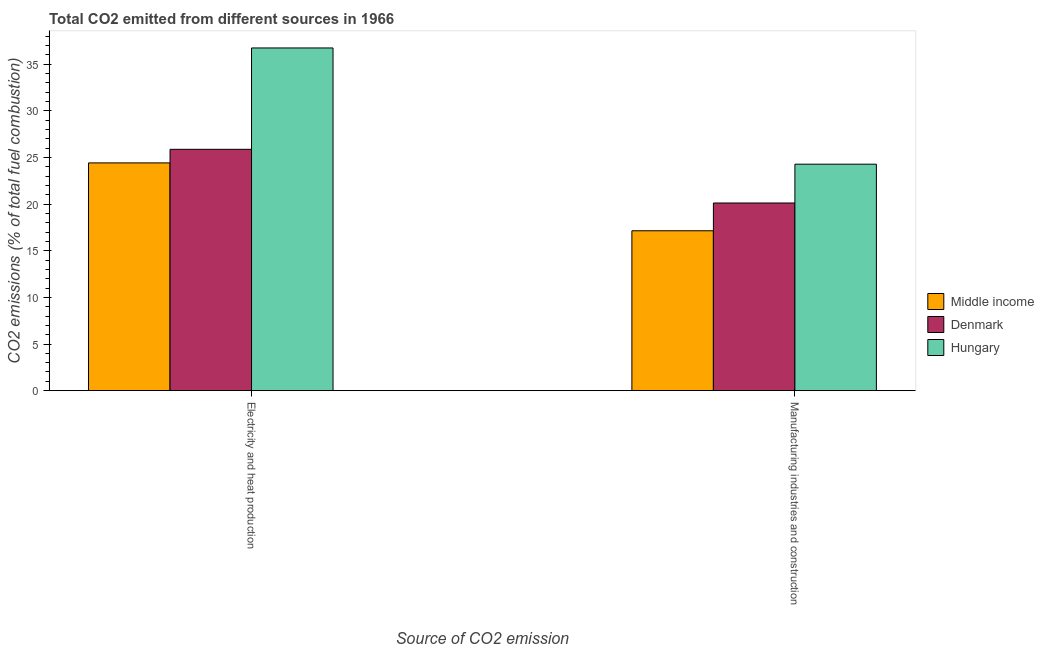How many different coloured bars are there?
Offer a terse response. 3. Are the number of bars per tick equal to the number of legend labels?
Offer a very short reply. Yes. Are the number of bars on each tick of the X-axis equal?
Your answer should be compact. Yes. How many bars are there on the 2nd tick from the left?
Your answer should be compact. 3. How many bars are there on the 2nd tick from the right?
Ensure brevity in your answer.  3. What is the label of the 1st group of bars from the left?
Your answer should be compact. Electricity and heat production. What is the co2 emissions due to electricity and heat production in Middle income?
Give a very brief answer. 24.43. Across all countries, what is the maximum co2 emissions due to electricity and heat production?
Your response must be concise. 36.75. Across all countries, what is the minimum co2 emissions due to manufacturing industries?
Ensure brevity in your answer.  17.15. In which country was the co2 emissions due to manufacturing industries maximum?
Offer a very short reply. Hungary. What is the total co2 emissions due to electricity and heat production in the graph?
Keep it short and to the point. 87.07. What is the difference between the co2 emissions due to manufacturing industries in Middle income and that in Hungary?
Your answer should be compact. -7.14. What is the difference between the co2 emissions due to manufacturing industries in Denmark and the co2 emissions due to electricity and heat production in Middle income?
Keep it short and to the point. -4.3. What is the average co2 emissions due to manufacturing industries per country?
Provide a succinct answer. 20.52. What is the difference between the co2 emissions due to manufacturing industries and co2 emissions due to electricity and heat production in Middle income?
Provide a short and direct response. -7.28. In how many countries, is the co2 emissions due to manufacturing industries greater than 34 %?
Your answer should be very brief. 0. What is the ratio of the co2 emissions due to electricity and heat production in Denmark to that in Middle income?
Make the answer very short. 1.06. Is the co2 emissions due to manufacturing industries in Denmark less than that in Middle income?
Your answer should be very brief. No. What does the 3rd bar from the left in Manufacturing industries and construction represents?
Provide a short and direct response. Hungary. How many bars are there?
Provide a short and direct response. 6. Are all the bars in the graph horizontal?
Provide a succinct answer. No. What is the difference between two consecutive major ticks on the Y-axis?
Offer a terse response. 5. Are the values on the major ticks of Y-axis written in scientific E-notation?
Your answer should be very brief. No. Does the graph contain any zero values?
Your response must be concise. No. Does the graph contain grids?
Ensure brevity in your answer.  No. Where does the legend appear in the graph?
Give a very brief answer. Center right. How many legend labels are there?
Your answer should be very brief. 3. What is the title of the graph?
Your answer should be very brief. Total CO2 emitted from different sources in 1966. Does "Brunei Darussalam" appear as one of the legend labels in the graph?
Provide a short and direct response. No. What is the label or title of the X-axis?
Your answer should be compact. Source of CO2 emission. What is the label or title of the Y-axis?
Make the answer very short. CO2 emissions (% of total fuel combustion). What is the CO2 emissions (% of total fuel combustion) of Middle income in Electricity and heat production?
Ensure brevity in your answer.  24.43. What is the CO2 emissions (% of total fuel combustion) in Denmark in Electricity and heat production?
Keep it short and to the point. 25.88. What is the CO2 emissions (% of total fuel combustion) of Hungary in Electricity and heat production?
Your answer should be very brief. 36.75. What is the CO2 emissions (% of total fuel combustion) of Middle income in Manufacturing industries and construction?
Ensure brevity in your answer.  17.15. What is the CO2 emissions (% of total fuel combustion) in Denmark in Manufacturing industries and construction?
Offer a very short reply. 20.13. What is the CO2 emissions (% of total fuel combustion) of Hungary in Manufacturing industries and construction?
Ensure brevity in your answer.  24.29. Across all Source of CO2 emission, what is the maximum CO2 emissions (% of total fuel combustion) in Middle income?
Provide a short and direct response. 24.43. Across all Source of CO2 emission, what is the maximum CO2 emissions (% of total fuel combustion) in Denmark?
Make the answer very short. 25.88. Across all Source of CO2 emission, what is the maximum CO2 emissions (% of total fuel combustion) in Hungary?
Your response must be concise. 36.75. Across all Source of CO2 emission, what is the minimum CO2 emissions (% of total fuel combustion) in Middle income?
Ensure brevity in your answer.  17.15. Across all Source of CO2 emission, what is the minimum CO2 emissions (% of total fuel combustion) of Denmark?
Give a very brief answer. 20.13. Across all Source of CO2 emission, what is the minimum CO2 emissions (% of total fuel combustion) in Hungary?
Provide a succinct answer. 24.29. What is the total CO2 emissions (% of total fuel combustion) in Middle income in the graph?
Your answer should be compact. 41.57. What is the total CO2 emissions (% of total fuel combustion) of Denmark in the graph?
Your response must be concise. 46.01. What is the total CO2 emissions (% of total fuel combustion) of Hungary in the graph?
Your answer should be compact. 61.04. What is the difference between the CO2 emissions (% of total fuel combustion) of Middle income in Electricity and heat production and that in Manufacturing industries and construction?
Provide a short and direct response. 7.28. What is the difference between the CO2 emissions (% of total fuel combustion) in Denmark in Electricity and heat production and that in Manufacturing industries and construction?
Ensure brevity in your answer.  5.76. What is the difference between the CO2 emissions (% of total fuel combustion) of Hungary in Electricity and heat production and that in Manufacturing industries and construction?
Offer a very short reply. 12.47. What is the difference between the CO2 emissions (% of total fuel combustion) of Middle income in Electricity and heat production and the CO2 emissions (% of total fuel combustion) of Denmark in Manufacturing industries and construction?
Your answer should be very brief. 4.3. What is the difference between the CO2 emissions (% of total fuel combustion) in Middle income in Electricity and heat production and the CO2 emissions (% of total fuel combustion) in Hungary in Manufacturing industries and construction?
Give a very brief answer. 0.14. What is the difference between the CO2 emissions (% of total fuel combustion) in Denmark in Electricity and heat production and the CO2 emissions (% of total fuel combustion) in Hungary in Manufacturing industries and construction?
Offer a very short reply. 1.59. What is the average CO2 emissions (% of total fuel combustion) of Middle income per Source of CO2 emission?
Ensure brevity in your answer.  20.79. What is the average CO2 emissions (% of total fuel combustion) of Denmark per Source of CO2 emission?
Your answer should be very brief. 23. What is the average CO2 emissions (% of total fuel combustion) in Hungary per Source of CO2 emission?
Give a very brief answer. 30.52. What is the difference between the CO2 emissions (% of total fuel combustion) in Middle income and CO2 emissions (% of total fuel combustion) in Denmark in Electricity and heat production?
Give a very brief answer. -1.46. What is the difference between the CO2 emissions (% of total fuel combustion) in Middle income and CO2 emissions (% of total fuel combustion) in Hungary in Electricity and heat production?
Keep it short and to the point. -12.33. What is the difference between the CO2 emissions (% of total fuel combustion) in Denmark and CO2 emissions (% of total fuel combustion) in Hungary in Electricity and heat production?
Provide a succinct answer. -10.87. What is the difference between the CO2 emissions (% of total fuel combustion) in Middle income and CO2 emissions (% of total fuel combustion) in Denmark in Manufacturing industries and construction?
Offer a terse response. -2.98. What is the difference between the CO2 emissions (% of total fuel combustion) in Middle income and CO2 emissions (% of total fuel combustion) in Hungary in Manufacturing industries and construction?
Offer a very short reply. -7.14. What is the difference between the CO2 emissions (% of total fuel combustion) in Denmark and CO2 emissions (% of total fuel combustion) in Hungary in Manufacturing industries and construction?
Make the answer very short. -4.16. What is the ratio of the CO2 emissions (% of total fuel combustion) in Middle income in Electricity and heat production to that in Manufacturing industries and construction?
Make the answer very short. 1.42. What is the ratio of the CO2 emissions (% of total fuel combustion) in Denmark in Electricity and heat production to that in Manufacturing industries and construction?
Your answer should be compact. 1.29. What is the ratio of the CO2 emissions (% of total fuel combustion) in Hungary in Electricity and heat production to that in Manufacturing industries and construction?
Offer a very short reply. 1.51. What is the difference between the highest and the second highest CO2 emissions (% of total fuel combustion) of Middle income?
Provide a short and direct response. 7.28. What is the difference between the highest and the second highest CO2 emissions (% of total fuel combustion) of Denmark?
Offer a very short reply. 5.76. What is the difference between the highest and the second highest CO2 emissions (% of total fuel combustion) in Hungary?
Provide a short and direct response. 12.47. What is the difference between the highest and the lowest CO2 emissions (% of total fuel combustion) in Middle income?
Offer a terse response. 7.28. What is the difference between the highest and the lowest CO2 emissions (% of total fuel combustion) of Denmark?
Provide a succinct answer. 5.76. What is the difference between the highest and the lowest CO2 emissions (% of total fuel combustion) in Hungary?
Offer a terse response. 12.47. 